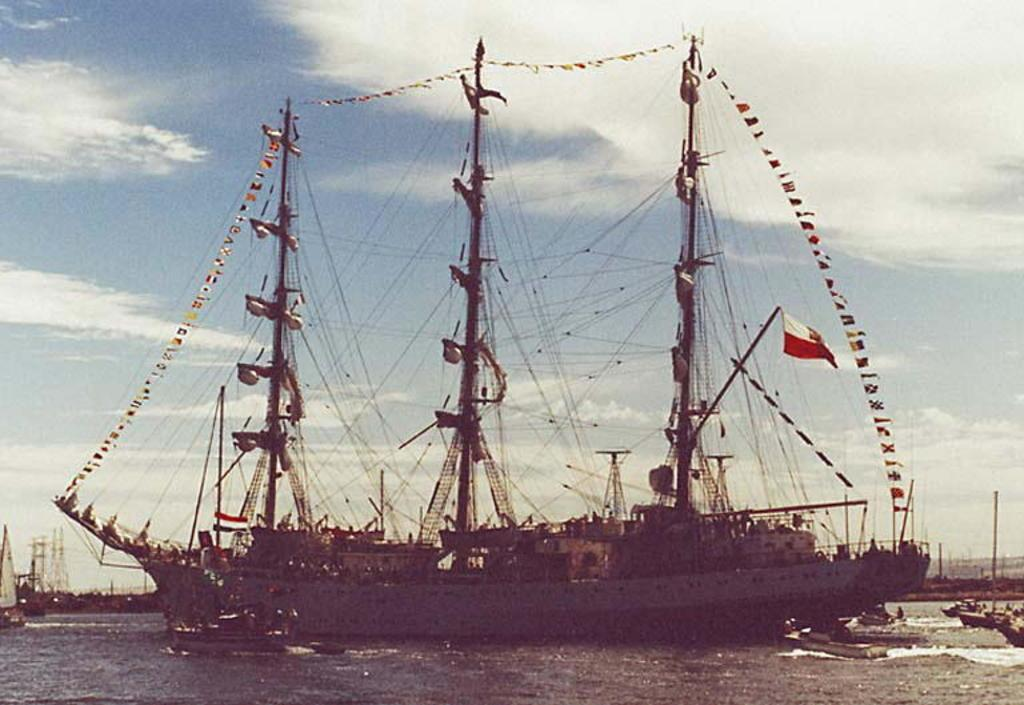What type of vehicles are in the image? There are boats and a ship in the image. Where are the boats and ship located? They are on the water in the image. What can be seen in the background of the image? The sky is visible in the background of the image. Can you see any ants crawling on the ship in the image? There are no ants visible in the image; it features boats and a ship on the water. Is there a rabbit hopping around the boats in the image? There is no rabbit present in the image; it only features boats and a ship on the water. 